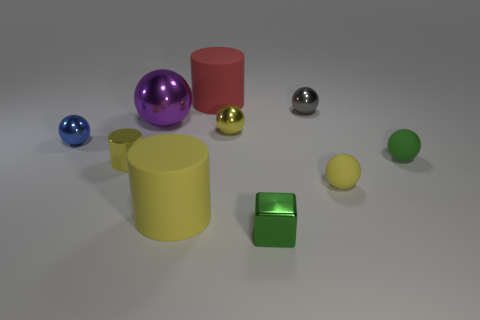Subtract all big purple metallic balls. How many balls are left? 5 Subtract all gray spheres. How many spheres are left? 5 Subtract 3 spheres. How many spheres are left? 3 Subtract all red spheres. Subtract all green cylinders. How many spheres are left? 6 Subtract all blocks. How many objects are left? 9 Add 6 large red things. How many large red things exist? 7 Subtract 0 purple blocks. How many objects are left? 10 Subtract all large brown metallic cubes. Subtract all tiny yellow things. How many objects are left? 7 Add 7 green rubber objects. How many green rubber objects are left? 8 